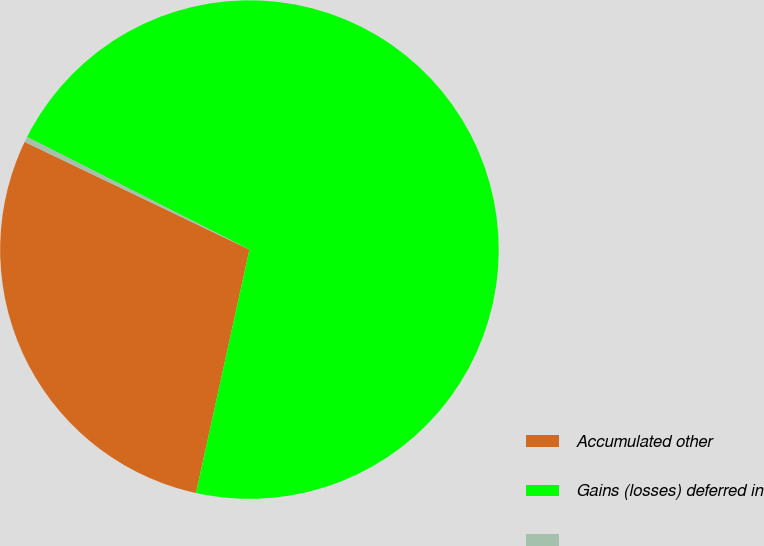<chart> <loc_0><loc_0><loc_500><loc_500><pie_chart><fcel>Accumulated other<fcel>Gains (losses) deferred in<fcel>Unnamed: 2<nl><fcel>28.67%<fcel>70.98%<fcel>0.35%<nl></chart> 